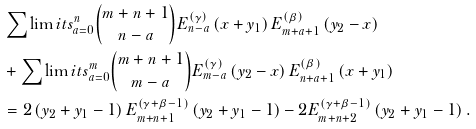Convert formula to latex. <formula><loc_0><loc_0><loc_500><loc_500>& \sum \lim i t s _ { a = 0 } ^ { n } \binom { m + n + 1 } { n - a } E _ { n - a } ^ { \left ( \gamma \right ) } \left ( x + y _ { 1 } \right ) E _ { m + a + 1 } ^ { \left ( \beta \right ) } \left ( y _ { 2 } - x \right ) \\ & + \sum \lim i t s _ { a = 0 } ^ { m } \binom { m + n + 1 } { m - a } E _ { m - a } ^ { \left ( \gamma \right ) } \left ( y _ { 2 } - x \right ) E _ { n + a + 1 } ^ { \left ( \beta \right ) } \left ( x + y _ { 1 } \right ) \\ & = 2 \left ( y _ { 2 } + y _ { 1 } - 1 \right ) E _ { m + n + 1 } ^ { \left ( \gamma + \beta - 1 \right ) } \left ( y _ { 2 } + y _ { 1 } - 1 \right ) - 2 E _ { m + n + 2 } ^ { \left ( \gamma + \beta - 1 \right ) } \left ( y _ { 2 } + y _ { 1 } - 1 \right ) .</formula> 